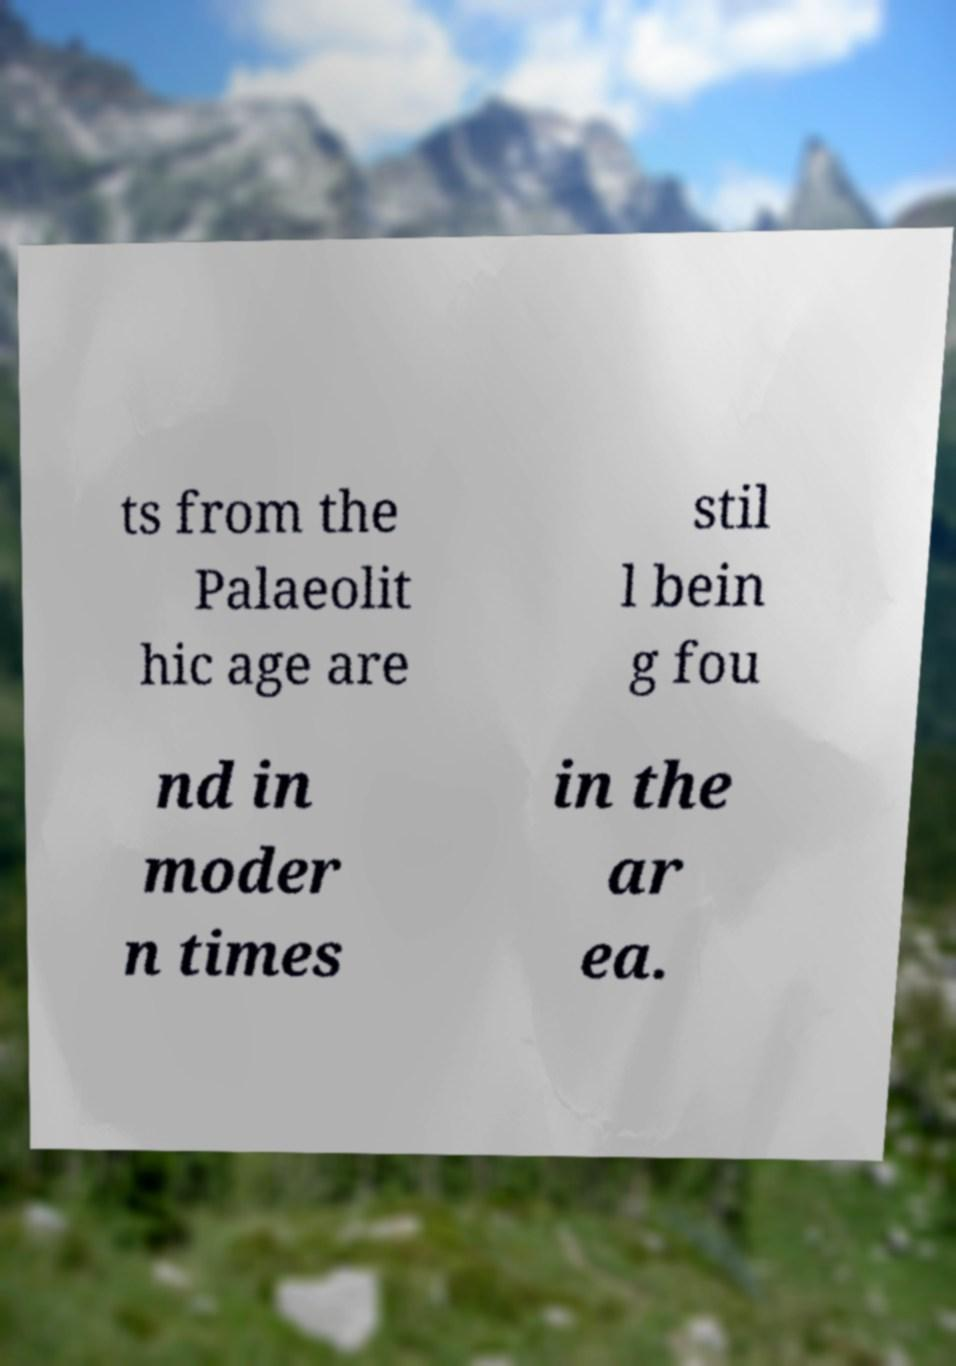Please identify and transcribe the text found in this image. ts from the Palaeolit hic age are stil l bein g fou nd in moder n times in the ar ea. 